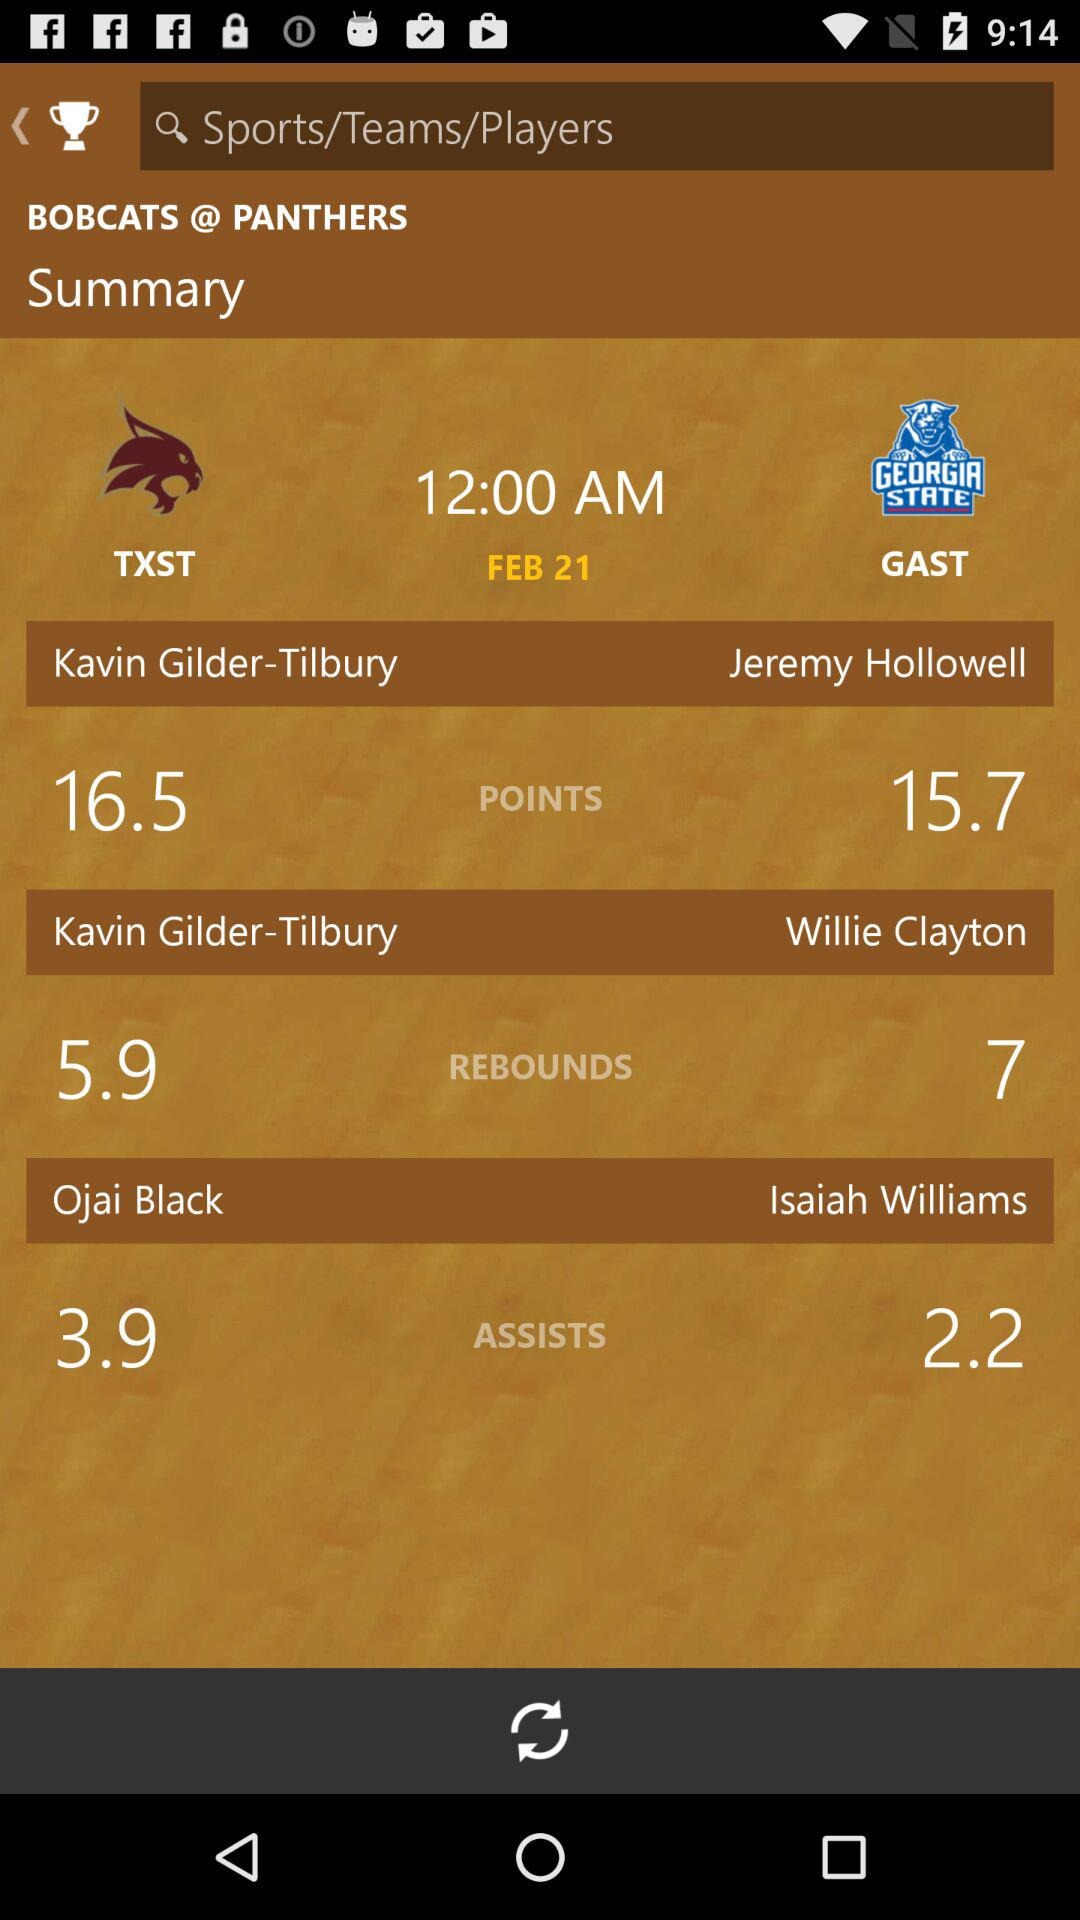What are the points of "Kavin Glider-Tribury"? The points of "Kavin Glider-Tribury" are 16.5. 